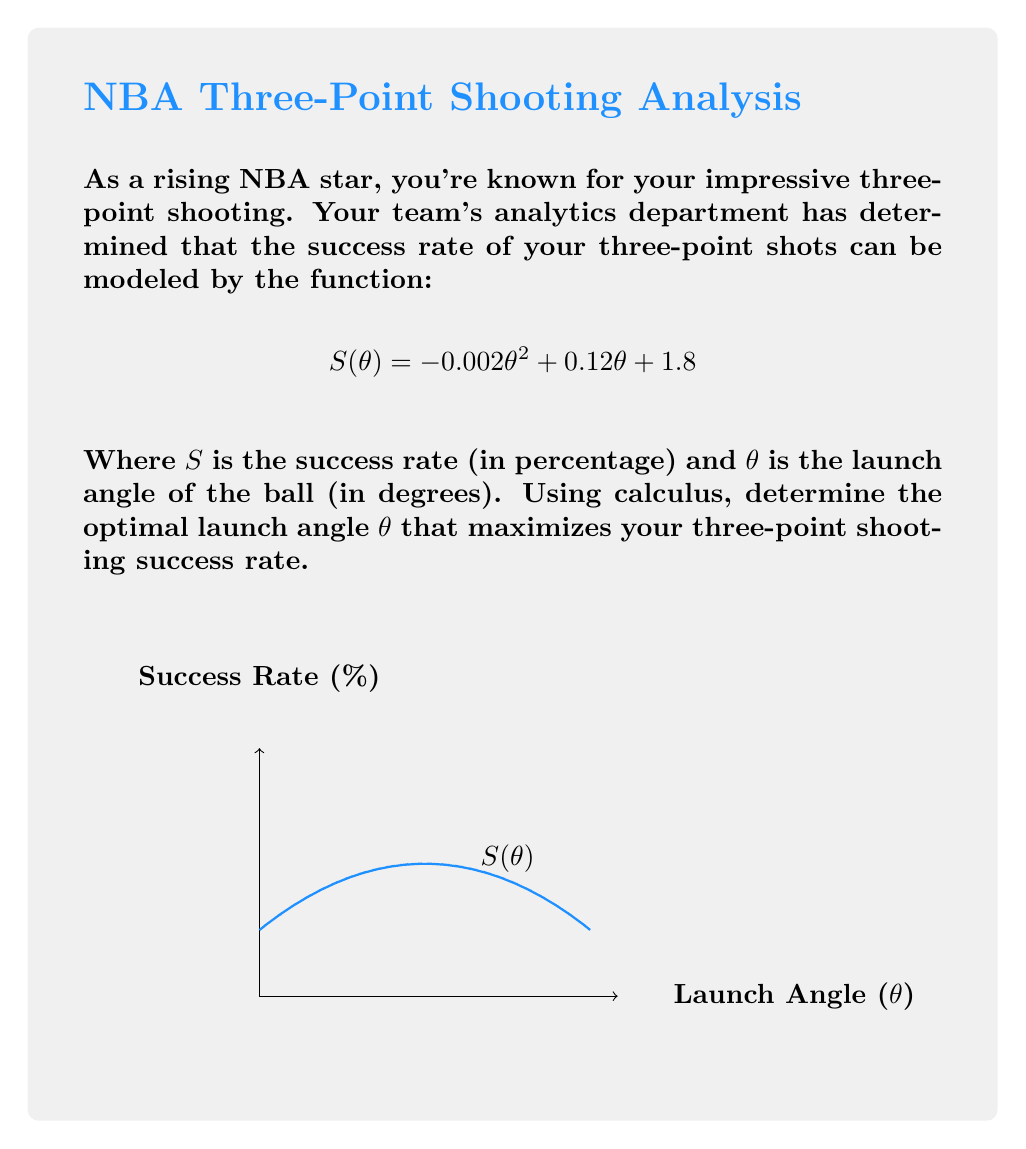Give your solution to this math problem. To find the optimal launch angle, we need to find the maximum of the function $S(\theta)$. This can be done by finding where the derivative of $S(\theta)$ equals zero.

Step 1: Find the derivative of $S(\theta)$
$$S'(\theta) = \frac{d}{d\theta}(-0.002\theta^2 + 0.12\theta + 1.8)$$
$$S'(\theta) = -0.004\theta + 0.12$$

Step 2: Set the derivative equal to zero and solve for $\theta$
$$-0.004\theta + 0.12 = 0$$
$$-0.004\theta = -0.12$$
$$\theta = \frac{-0.12}{-0.004} = 30$$

Step 3: Verify this is a maximum by checking the second derivative
$$S''(\theta) = -0.004$$
Since $S''(\theta)$ is negative, this confirms that $\theta = 30$ gives a maximum.

Step 4: Calculate the maximum success rate
$$S(30) = -0.002(30)^2 + 0.12(30) + 1.8$$
$$S(30) = -1.8 + 3.6 + 1.8 = 3.6$$

Therefore, the optimal launch angle is 30 degrees, which gives a maximum success rate of 3.6%.
Answer: 30 degrees 